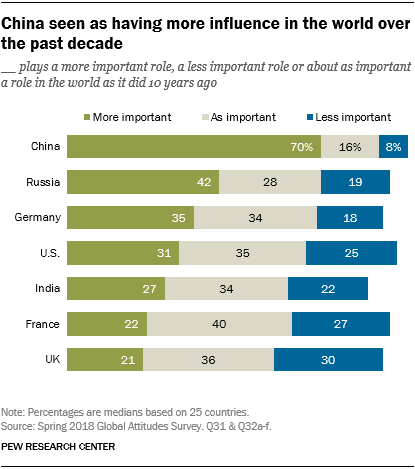Outline some significant characteristics in this image. The average of the three categories, including more important (26.67), as important (36.33), and less important (24.67), is 30.67. The data for India is important in the chart and is shown to be 0.34. 